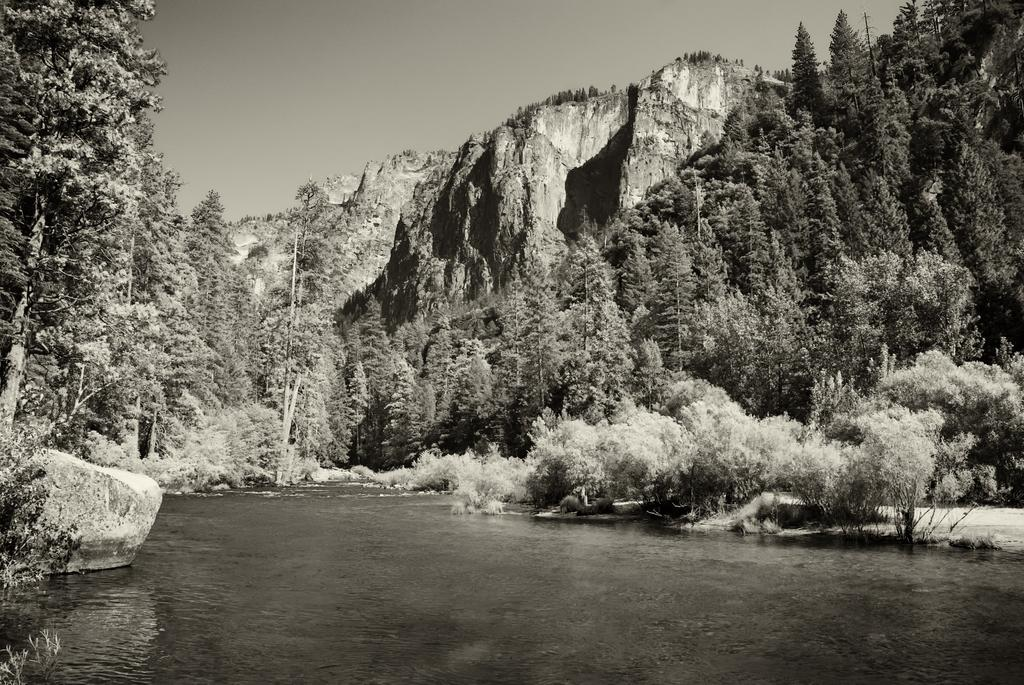What is the primary element in the image? The image consists of water. What can be seen on the left side of the image? There is a rock on the left side of the image. What type of vegetation is present in the front of the image? There are many trees and plants in the front of the image. What geographical features are visible at the top of the image? Mountains and the sky are visible at the top of the image. What type of stamp can be seen on the knee of the person in the image? There is no person present in the image, and therefore no knee or stamp can be observed. 